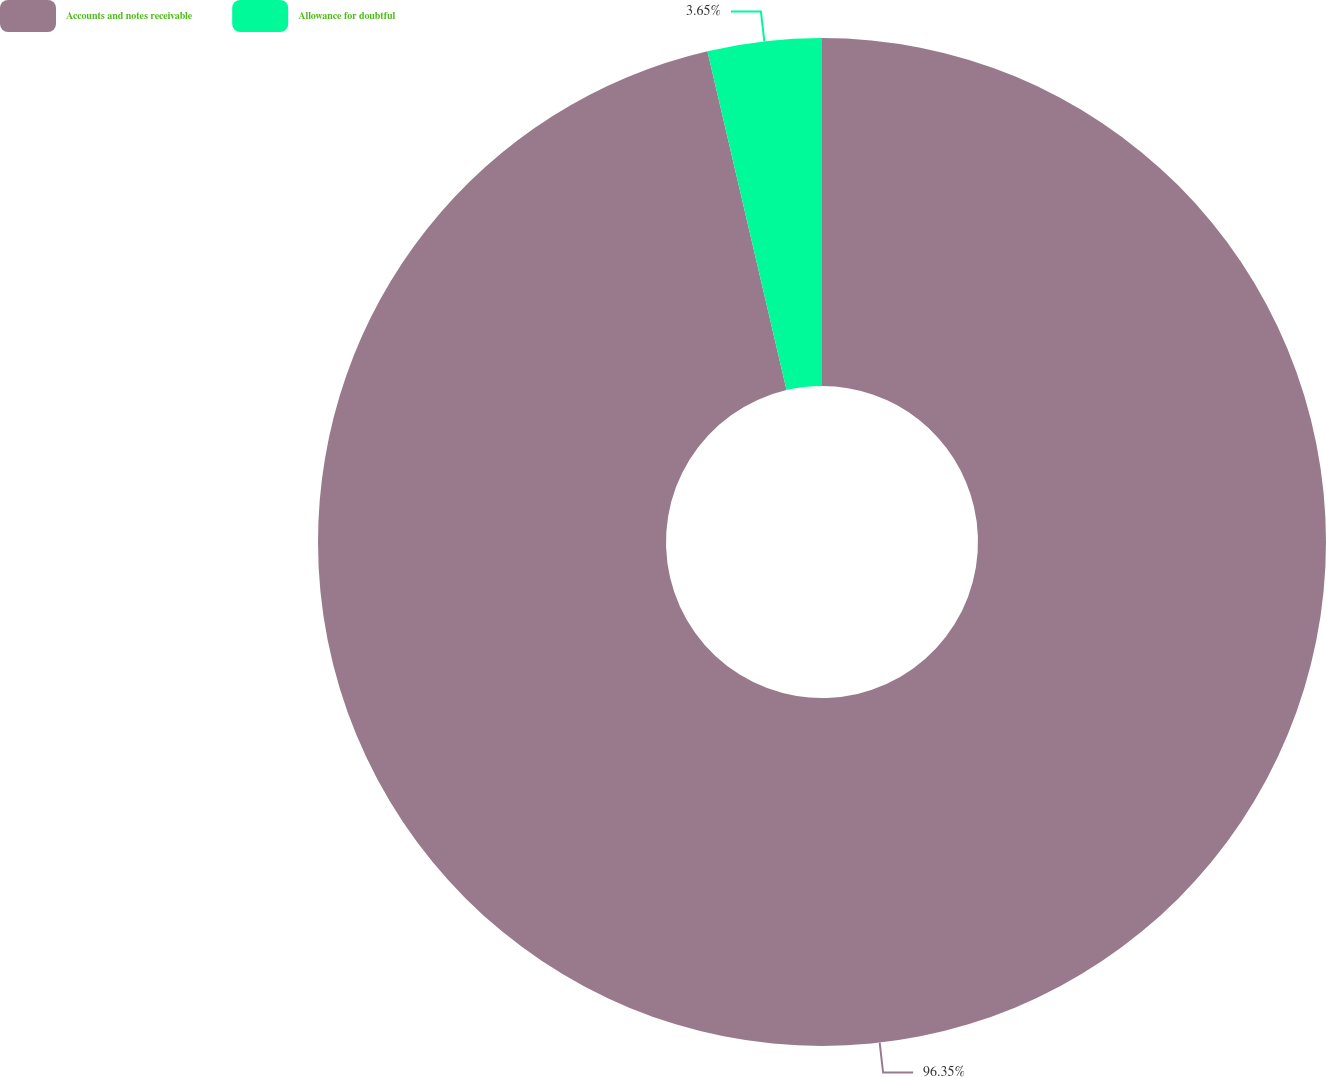Convert chart to OTSL. <chart><loc_0><loc_0><loc_500><loc_500><pie_chart><fcel>Accounts and notes receivable<fcel>Allowance for doubtful<nl><fcel>96.35%<fcel>3.65%<nl></chart> 